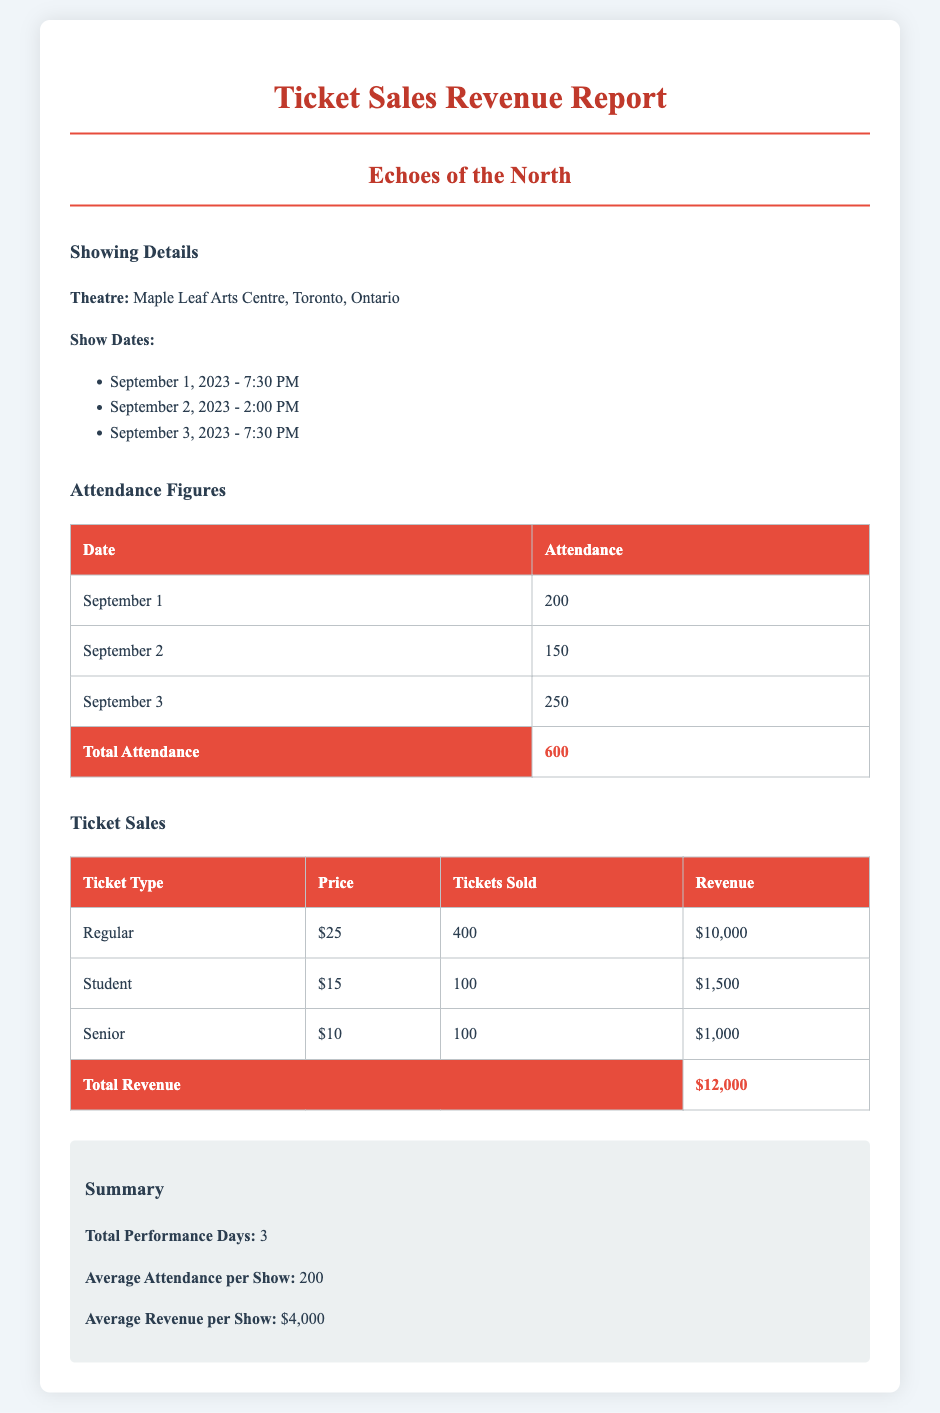What is the total attendance? The total attendance is calculated by adding the attendance figures of all show dates, which is 200 + 150 + 250 = 600.
Answer: 600 What was the ticket price for Senior tickets? The ticket price for Senior tickets is listed as $10 in the ticket sales section of the document.
Answer: $10 How many shows were held in total? The document lists three different show dates, so the total number of performances is three.
Answer: 3 What was the average revenue per show? The average revenue per show is provided in the summary section, which indicates the total revenue divided by the total performance days: $12,000 / 3 = $4,000.
Answer: $4,000 How many regular tickets were sold? The number of regular tickets sold is specified in the ticket sales table, which states that 400 regular tickets were sold.
Answer: 400 What is the total revenue from Student tickets? The total revenue from Student tickets can be calculated from the table, which shows 100 Student tickets sold at $15 each, totaling $1,500.
Answer: $1,500 What date had the highest attendance? Looking at the attendance figures, September 3 shows the highest attendance at 250 people.
Answer: September 3 How much revenue was generated from Regular tickets? The revenue generated from Regular tickets is stated in the ticket sales table as $10,000.
Answer: $10,000 What is the theatre's name? The name of the theatre is mentioned in the showing details section, which identifies it as Maple Leaf Arts Centre.
Answer: Maple Leaf Arts Centre 